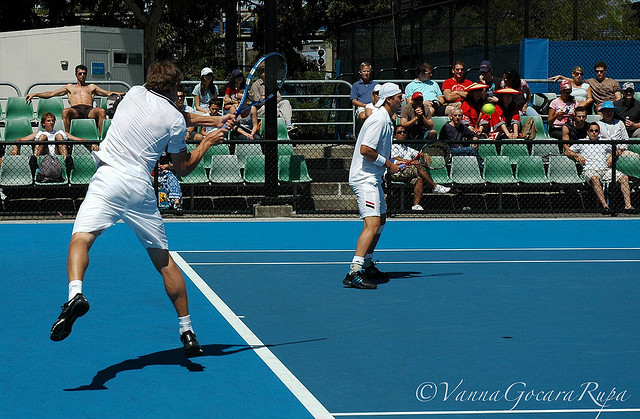Identify the text contained in this image. gocara Rupa 